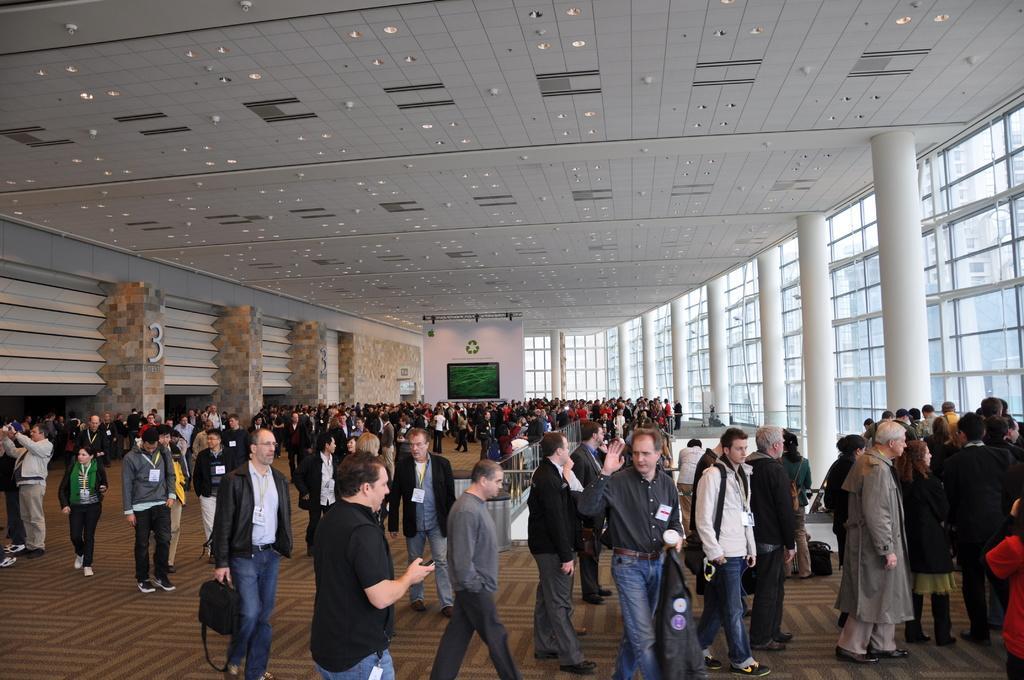Please provide a concise description of this image. This image consists of many persons. It looks like a conference hall. At the top, there are lights fixed to the roof. To the right, there are pillars. To the left, there are gateways. At the bottom, there is a floor. 